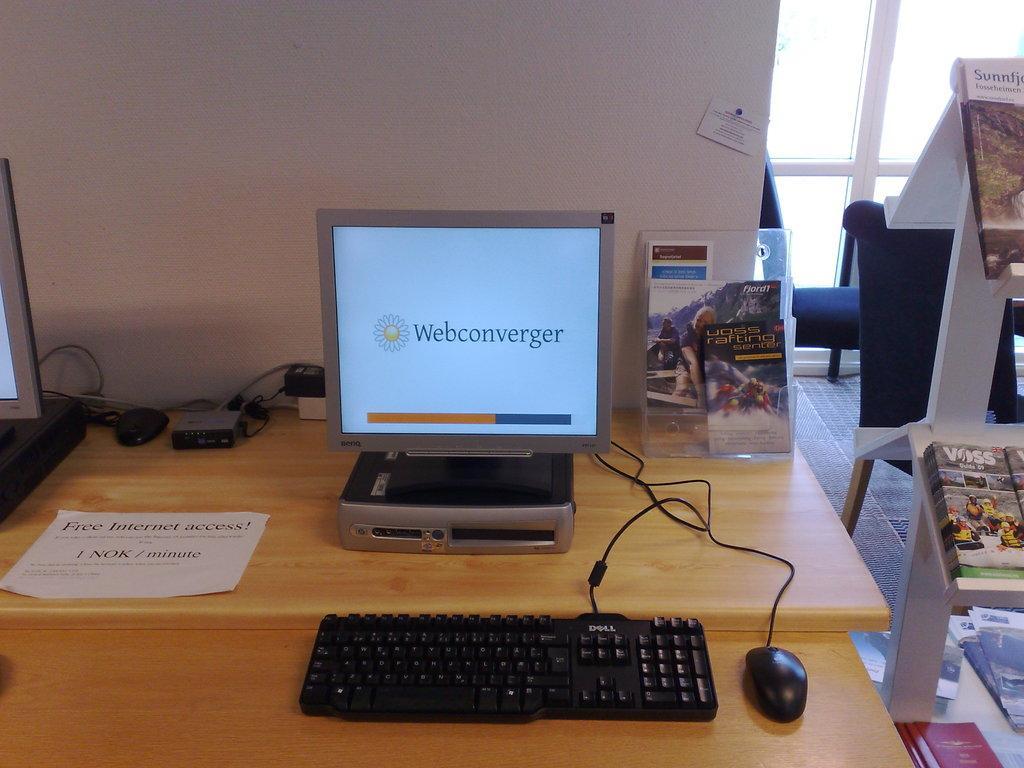In one or two sentences, can you explain what this image depicts? This is a picture from a store or office. In the foreground of the picture there is a desk, on the desk there is a desktop, a keyboard and a mouse. To the right there is it cupboard, in the cupboard there are books. To the top right there are chairs and a window. On the background there is a wall. 